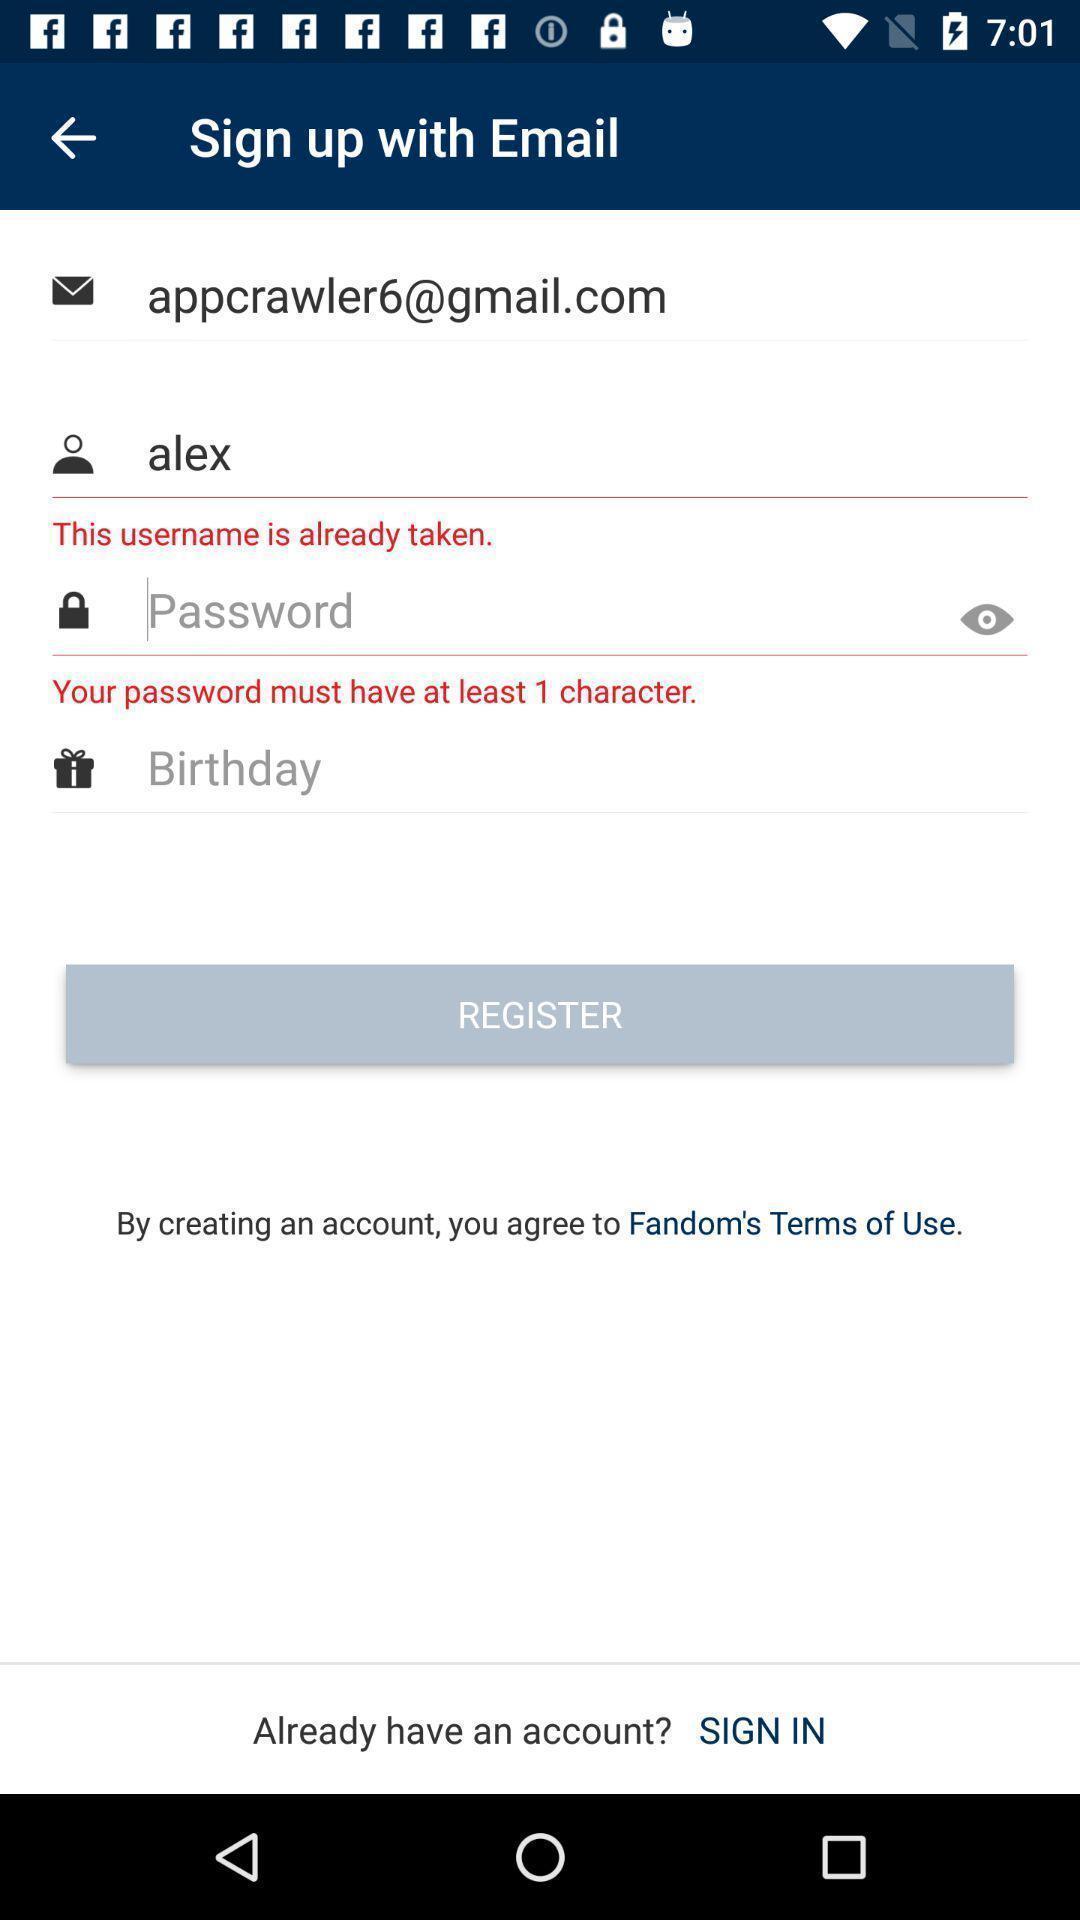Give me a summary of this screen capture. Sign up and register page for application with entry details. 